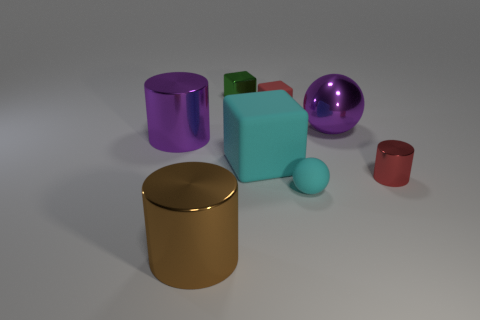What time of day do you think it is in this image? The image appears to be rendered in a controlled lighting environment, rather than depicting a natural setting. There are no indicators of a specific time of day, as the lighting is artificial and consistent, casting soft shadows and highlights on the objects. 